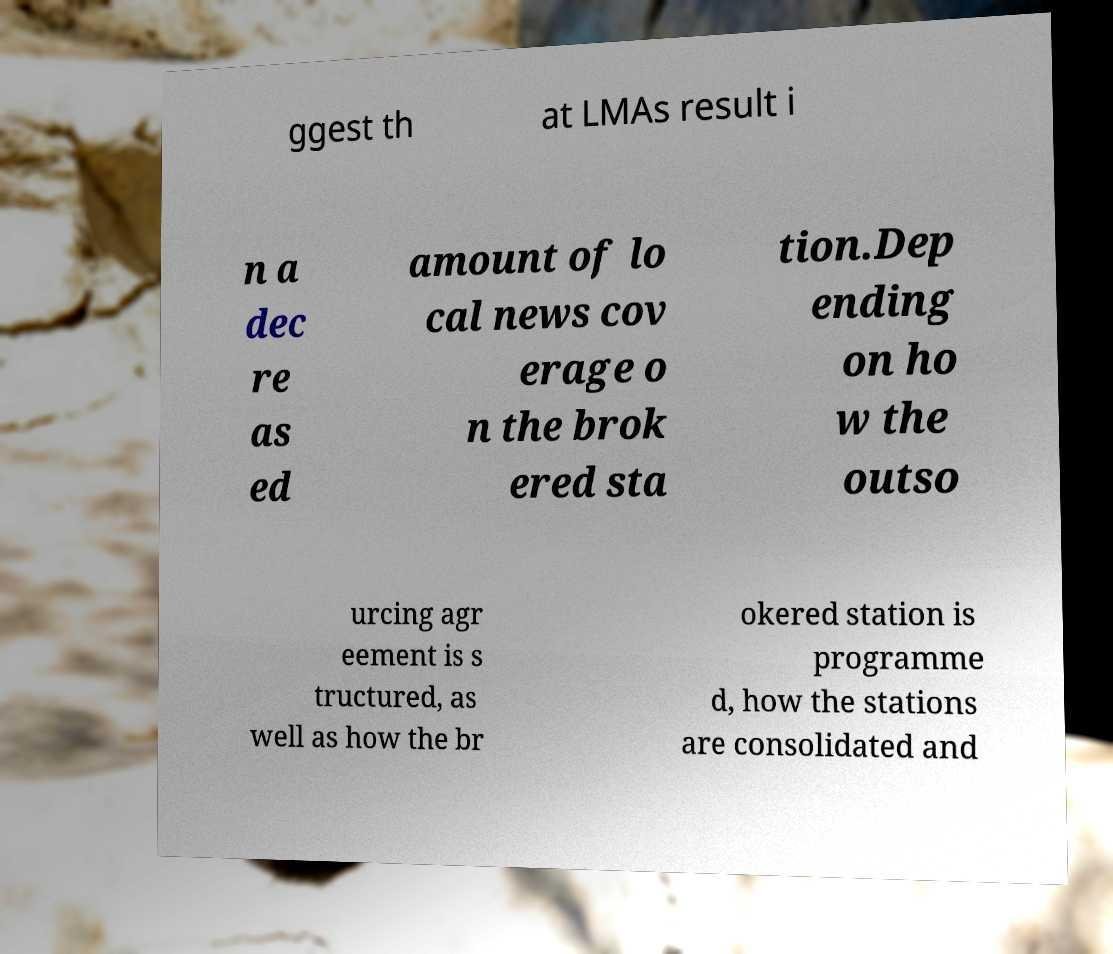What messages or text are displayed in this image? I need them in a readable, typed format. ggest th at LMAs result i n a dec re as ed amount of lo cal news cov erage o n the brok ered sta tion.Dep ending on ho w the outso urcing agr eement is s tructured, as well as how the br okered station is programme d, how the stations are consolidated and 